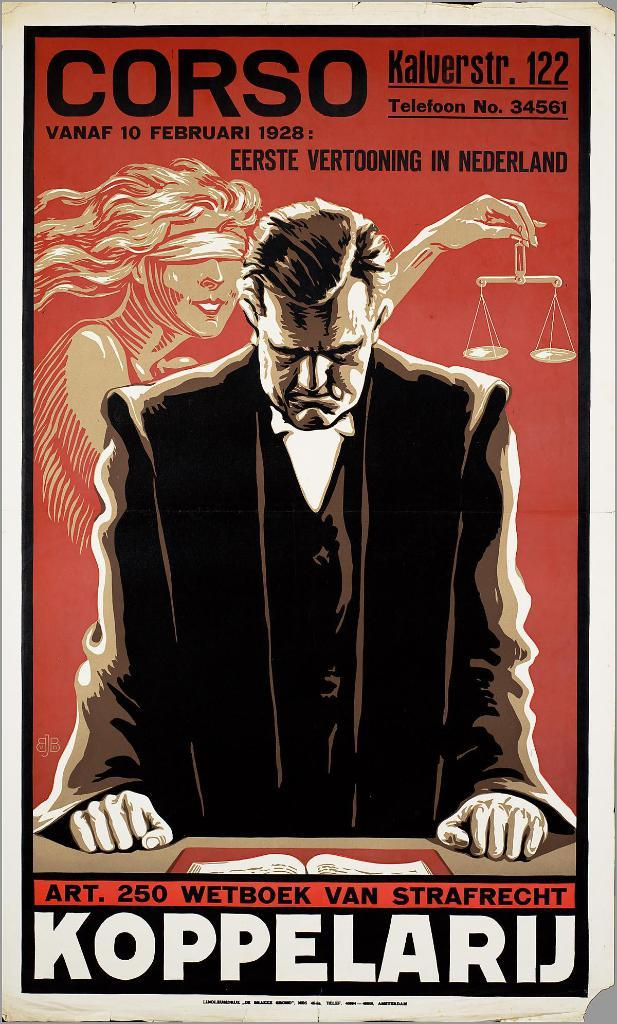<image>
Render a clear and concise summary of the photo. a poster with CORSO and KOPPELARIJ  on it. 